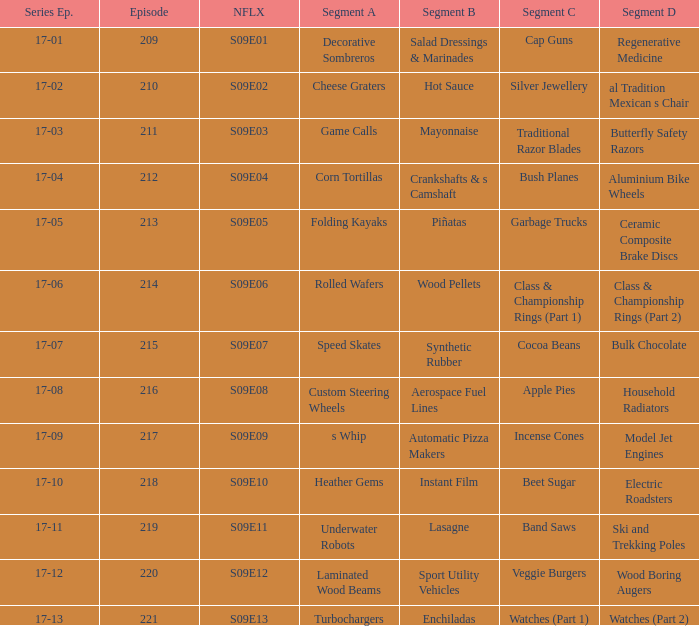Episode smaller than 210 had what segment c? Cap Guns. 